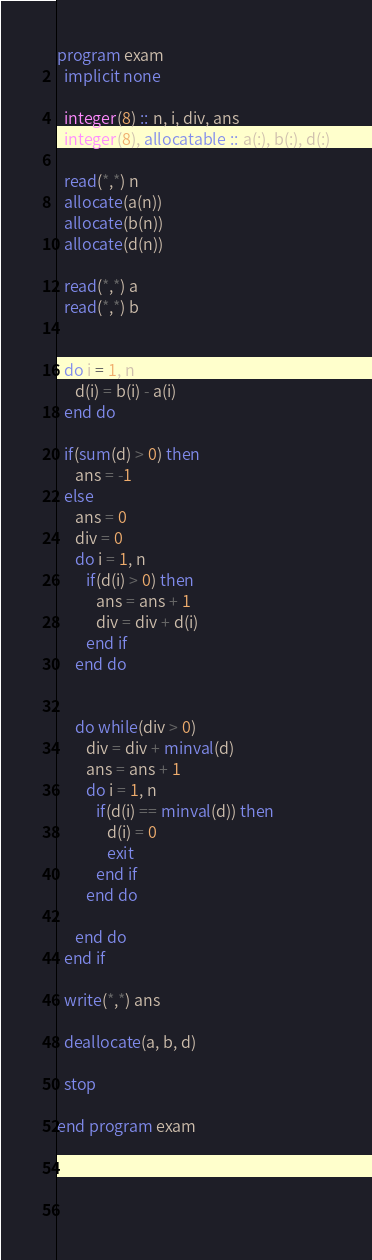Convert code to text. <code><loc_0><loc_0><loc_500><loc_500><_FORTRAN_>program exam
  implicit none

  integer(8) :: n, i, div, ans
  integer(8), allocatable :: a(:), b(:), d(:)

  read(*,*) n
  allocate(a(n))
  allocate(b(n))
  allocate(d(n))

  read(*,*) a
  read(*,*) b

  
  do i = 1, n
     d(i) = b(i) - a(i)
  end do

  if(sum(d) > 0) then
     ans = -1
  else
     ans = 0
     div = 0
     do i = 1, n
        if(d(i) > 0) then
           ans = ans + 1
           div = div + d(i)
        end if
     end do

     
     do while(div > 0)
        div = div + minval(d)
        ans = ans + 1
        do i = 1, n
           if(d(i) == minval(d)) then
              d(i) = 0
              exit
           end if
        end do
 
     end do
  end if
  
  write(*,*) ans

  deallocate(a, b, d)

  stop

end program exam


           
        
</code> 